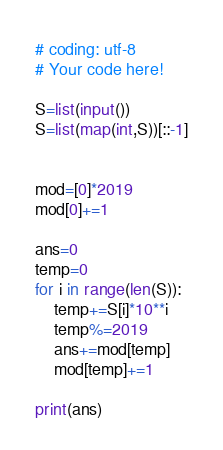Convert code to text. <code><loc_0><loc_0><loc_500><loc_500><_Python_># coding: utf-8
# Your code here!

S=list(input())
S=list(map(int,S))[::-1]


mod=[0]*2019
mod[0]+=1

ans=0
temp=0
for i in range(len(S)):
    temp+=S[i]*10**i
    temp%=2019
    ans+=mod[temp]
    mod[temp]+=1

print(ans)
</code> 